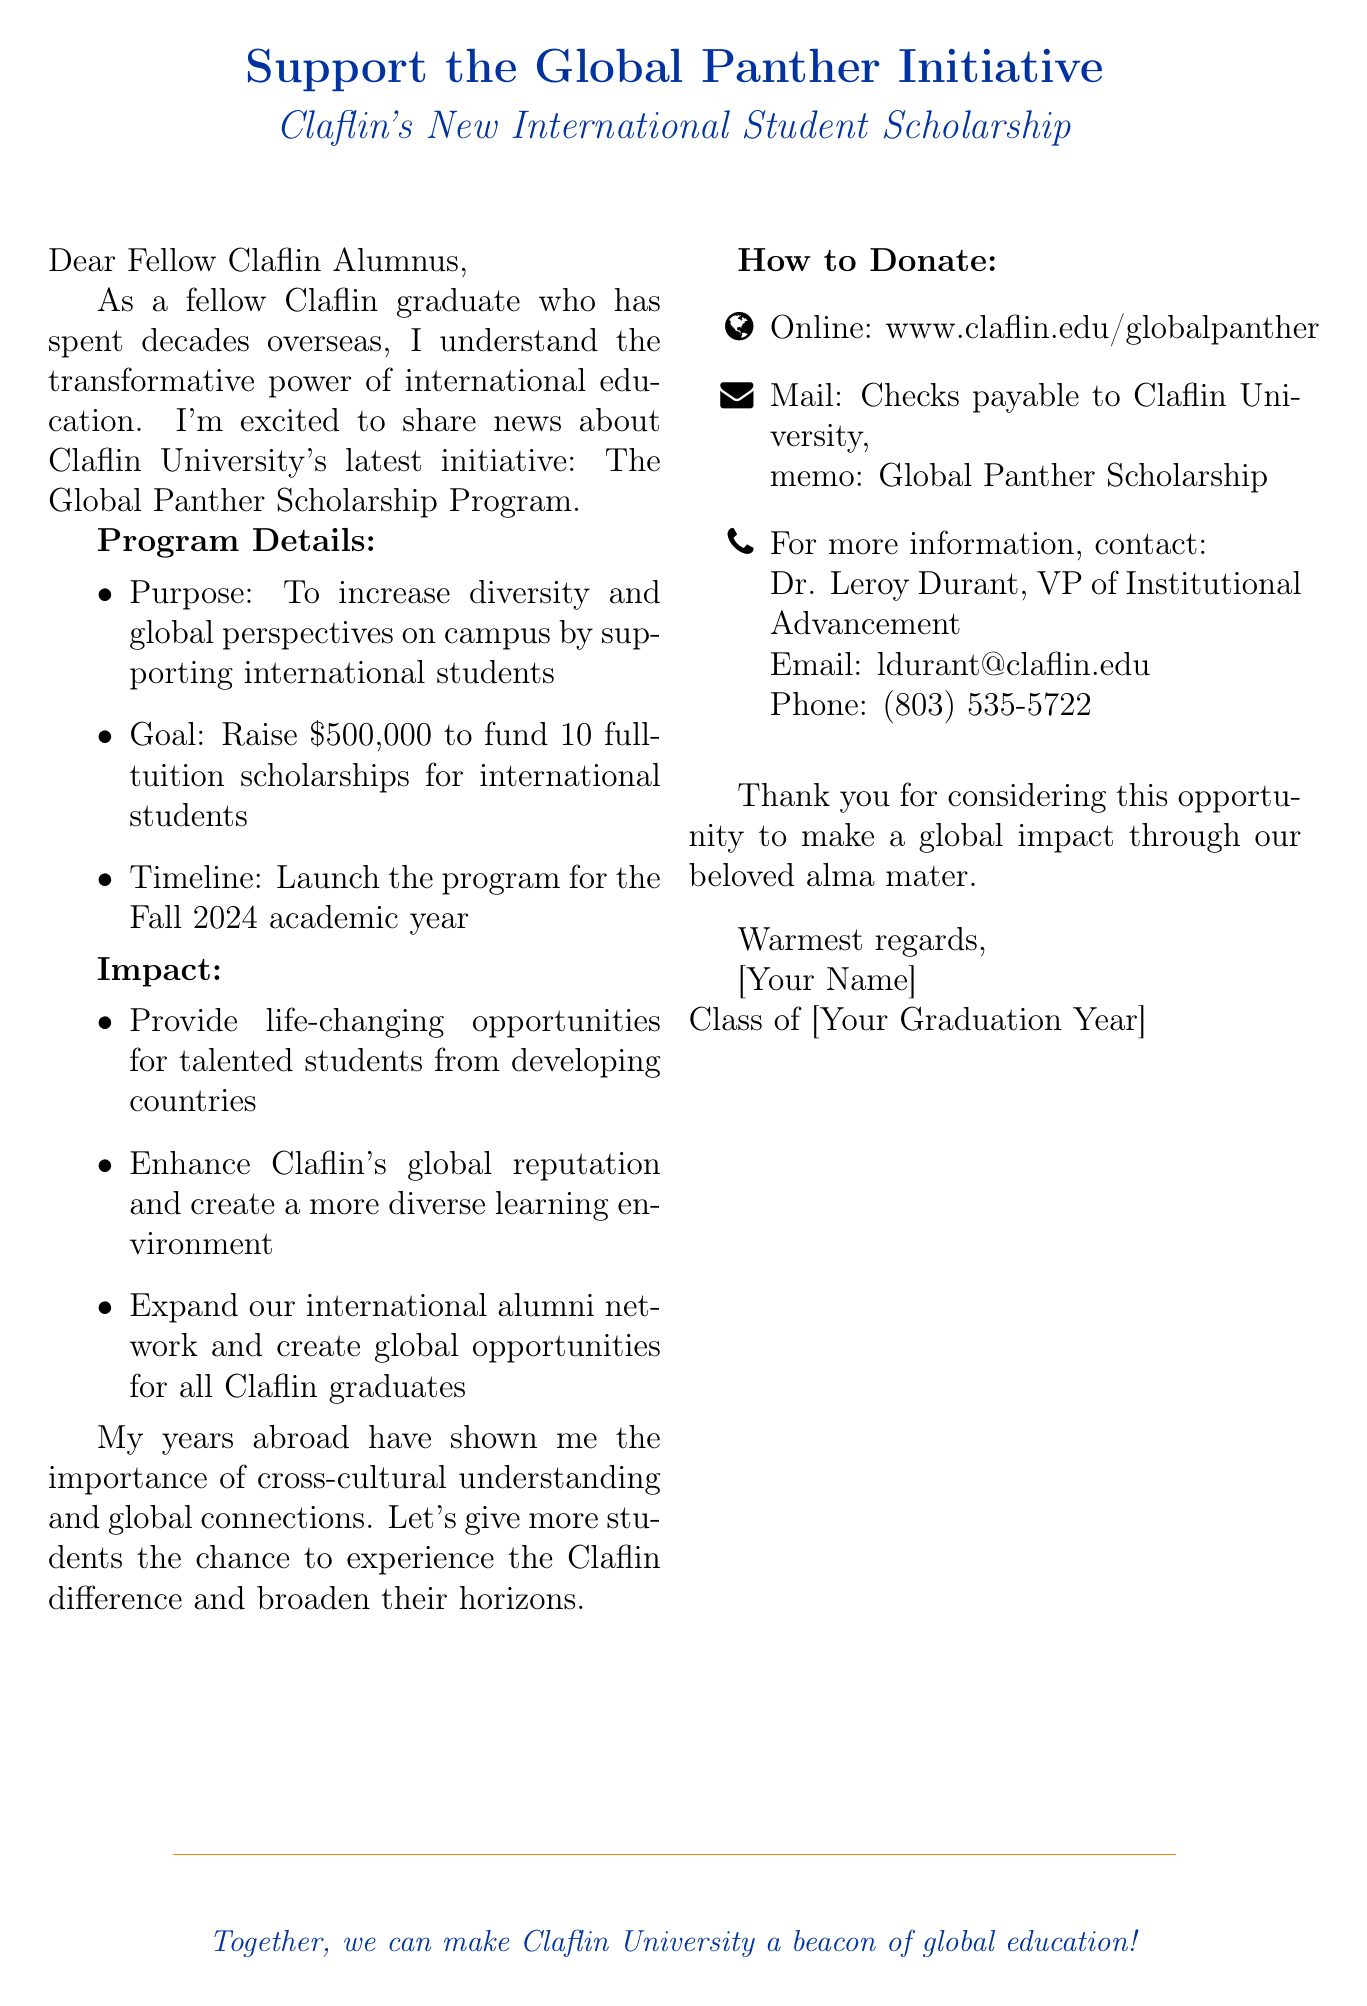What is the name of the scholarship program? The scholarship program is referred to as the Global Panther Scholarship Program in the document.
Answer: Global Panther Scholarship Program What is the funding goal for the scholarship program? The document states that the goal is to raise $500,000 to fund scholarships.
Answer: $500,000 How many full-tuition scholarships are intended to be funded? According to the document, the program aims to fund 10 full-tuition scholarships for international students.
Answer: 10 When is the program scheduled to launch? The document mentions that the program will launch for the Fall 2024 academic year.
Answer: Fall 2024 What is one benefit of the scholarship program for students? The document states that the program aims to provide life-changing opportunities for talented students from developing countries.
Answer: Life-changing opportunities What underlying theme does the personal appeal focus on? The personal appeal highlights the importance of cross-cultural understanding and global connections based on the sender's experiences abroad.
Answer: Cross-cultural understanding Who is the contact person for more information about the initiative? The document indicates that Dr. Leroy Durant is the contact person for further information on the scholarship program.
Answer: Dr. Leroy Durant What online platform can donations be made through? The document provides a website where donations can be made securely for the scholarship program.
Answer: www.claflin.edu/globalpanther What color is associated with Claflin University in the document? The document specifies the color "claflinblue" as associated with Claflin University.
Answer: claflinblue 